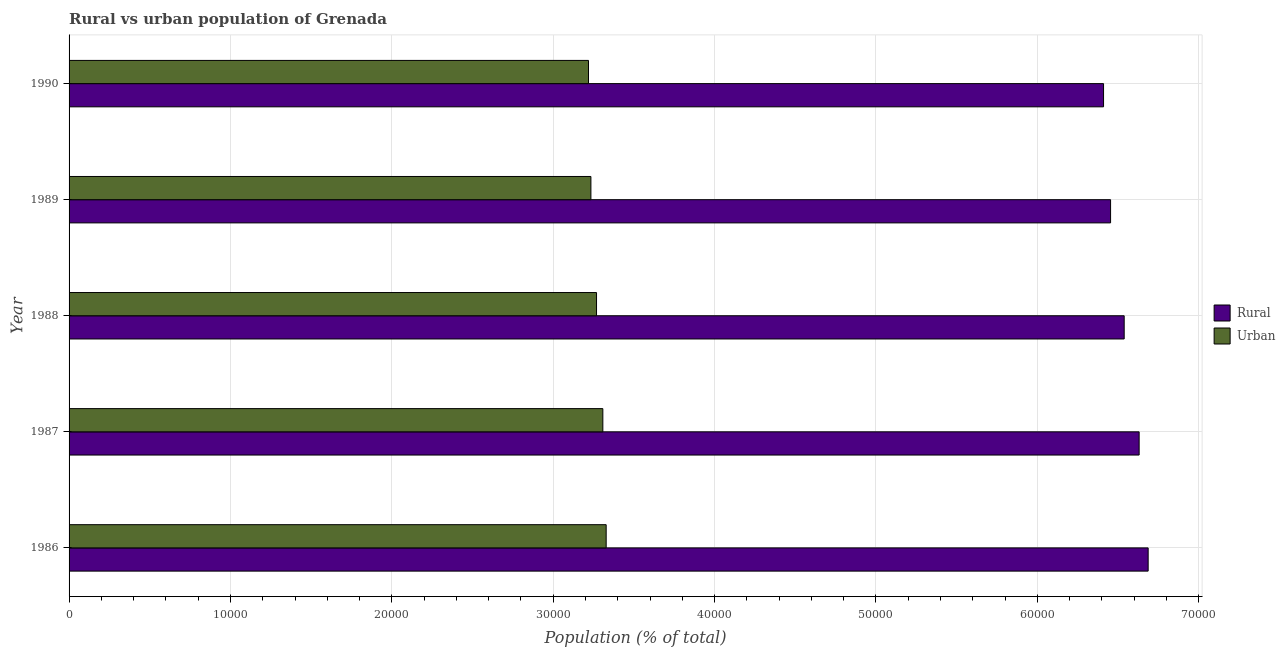How many different coloured bars are there?
Give a very brief answer. 2. Are the number of bars on each tick of the Y-axis equal?
Provide a succinct answer. Yes. How many bars are there on the 1st tick from the top?
Keep it short and to the point. 2. What is the label of the 2nd group of bars from the top?
Make the answer very short. 1989. What is the rural population density in 1986?
Keep it short and to the point. 6.69e+04. Across all years, what is the maximum urban population density?
Offer a terse response. 3.33e+04. Across all years, what is the minimum rural population density?
Offer a very short reply. 6.41e+04. What is the total rural population density in the graph?
Offer a terse response. 3.27e+05. What is the difference between the rural population density in 1986 and that in 1989?
Provide a short and direct response. 2329. What is the difference between the rural population density in 1988 and the urban population density in 1986?
Your response must be concise. 3.21e+04. What is the average rural population density per year?
Provide a succinct answer. 6.54e+04. In the year 1988, what is the difference between the urban population density and rural population density?
Provide a short and direct response. -3.27e+04. What is the ratio of the urban population density in 1986 to that in 1990?
Provide a short and direct response. 1.03. Is the rural population density in 1987 less than that in 1990?
Provide a short and direct response. No. What is the difference between the highest and the second highest urban population density?
Provide a short and direct response. 206. What is the difference between the highest and the lowest rural population density?
Offer a terse response. 2765. In how many years, is the urban population density greater than the average urban population density taken over all years?
Make the answer very short. 2. Is the sum of the rural population density in 1987 and 1988 greater than the maximum urban population density across all years?
Keep it short and to the point. Yes. What does the 2nd bar from the top in 1987 represents?
Give a very brief answer. Rural. What does the 2nd bar from the bottom in 1988 represents?
Your response must be concise. Urban. Are the values on the major ticks of X-axis written in scientific E-notation?
Ensure brevity in your answer.  No. Does the graph contain any zero values?
Make the answer very short. No. Where does the legend appear in the graph?
Give a very brief answer. Center right. How are the legend labels stacked?
Provide a short and direct response. Vertical. What is the title of the graph?
Make the answer very short. Rural vs urban population of Grenada. Does "Private credit bureau" appear as one of the legend labels in the graph?
Keep it short and to the point. No. What is the label or title of the X-axis?
Offer a very short reply. Population (% of total). What is the Population (% of total) in Rural in 1986?
Offer a very short reply. 6.69e+04. What is the Population (% of total) of Urban in 1986?
Provide a succinct answer. 3.33e+04. What is the Population (% of total) in Rural in 1987?
Your answer should be compact. 6.63e+04. What is the Population (% of total) in Urban in 1987?
Your response must be concise. 3.31e+04. What is the Population (% of total) of Rural in 1988?
Provide a succinct answer. 6.54e+04. What is the Population (% of total) in Urban in 1988?
Ensure brevity in your answer.  3.27e+04. What is the Population (% of total) in Rural in 1989?
Give a very brief answer. 6.45e+04. What is the Population (% of total) of Urban in 1989?
Keep it short and to the point. 3.23e+04. What is the Population (% of total) in Rural in 1990?
Provide a short and direct response. 6.41e+04. What is the Population (% of total) of Urban in 1990?
Your response must be concise. 3.22e+04. Across all years, what is the maximum Population (% of total) of Rural?
Make the answer very short. 6.69e+04. Across all years, what is the maximum Population (% of total) of Urban?
Provide a short and direct response. 3.33e+04. Across all years, what is the minimum Population (% of total) in Rural?
Give a very brief answer. 6.41e+04. Across all years, what is the minimum Population (% of total) of Urban?
Provide a short and direct response. 3.22e+04. What is the total Population (% of total) in Rural in the graph?
Offer a terse response. 3.27e+05. What is the total Population (% of total) of Urban in the graph?
Provide a succinct answer. 1.64e+05. What is the difference between the Population (% of total) of Rural in 1986 and that in 1987?
Ensure brevity in your answer.  559. What is the difference between the Population (% of total) of Urban in 1986 and that in 1987?
Provide a succinct answer. 206. What is the difference between the Population (% of total) of Rural in 1986 and that in 1988?
Your response must be concise. 1486. What is the difference between the Population (% of total) of Urban in 1986 and that in 1988?
Your answer should be very brief. 597. What is the difference between the Population (% of total) in Rural in 1986 and that in 1989?
Give a very brief answer. 2329. What is the difference between the Population (% of total) of Urban in 1986 and that in 1989?
Your answer should be compact. 946. What is the difference between the Population (% of total) of Rural in 1986 and that in 1990?
Make the answer very short. 2765. What is the difference between the Population (% of total) of Urban in 1986 and that in 1990?
Your response must be concise. 1095. What is the difference between the Population (% of total) of Rural in 1987 and that in 1988?
Your response must be concise. 927. What is the difference between the Population (% of total) in Urban in 1987 and that in 1988?
Your answer should be compact. 391. What is the difference between the Population (% of total) of Rural in 1987 and that in 1989?
Give a very brief answer. 1770. What is the difference between the Population (% of total) of Urban in 1987 and that in 1989?
Keep it short and to the point. 740. What is the difference between the Population (% of total) in Rural in 1987 and that in 1990?
Your response must be concise. 2206. What is the difference between the Population (% of total) in Urban in 1987 and that in 1990?
Give a very brief answer. 889. What is the difference between the Population (% of total) of Rural in 1988 and that in 1989?
Ensure brevity in your answer.  843. What is the difference between the Population (% of total) in Urban in 1988 and that in 1989?
Offer a very short reply. 349. What is the difference between the Population (% of total) in Rural in 1988 and that in 1990?
Give a very brief answer. 1279. What is the difference between the Population (% of total) of Urban in 1988 and that in 1990?
Make the answer very short. 498. What is the difference between the Population (% of total) in Rural in 1989 and that in 1990?
Your response must be concise. 436. What is the difference between the Population (% of total) in Urban in 1989 and that in 1990?
Your answer should be very brief. 149. What is the difference between the Population (% of total) in Rural in 1986 and the Population (% of total) in Urban in 1987?
Give a very brief answer. 3.38e+04. What is the difference between the Population (% of total) of Rural in 1986 and the Population (% of total) of Urban in 1988?
Give a very brief answer. 3.42e+04. What is the difference between the Population (% of total) of Rural in 1986 and the Population (% of total) of Urban in 1989?
Your response must be concise. 3.45e+04. What is the difference between the Population (% of total) in Rural in 1986 and the Population (% of total) in Urban in 1990?
Provide a short and direct response. 3.47e+04. What is the difference between the Population (% of total) of Rural in 1987 and the Population (% of total) of Urban in 1988?
Provide a succinct answer. 3.36e+04. What is the difference between the Population (% of total) of Rural in 1987 and the Population (% of total) of Urban in 1989?
Provide a short and direct response. 3.40e+04. What is the difference between the Population (% of total) in Rural in 1987 and the Population (% of total) in Urban in 1990?
Your response must be concise. 3.41e+04. What is the difference between the Population (% of total) in Rural in 1988 and the Population (% of total) in Urban in 1989?
Make the answer very short. 3.30e+04. What is the difference between the Population (% of total) in Rural in 1988 and the Population (% of total) in Urban in 1990?
Provide a succinct answer. 3.32e+04. What is the difference between the Population (% of total) in Rural in 1989 and the Population (% of total) in Urban in 1990?
Offer a terse response. 3.24e+04. What is the average Population (% of total) of Rural per year?
Ensure brevity in your answer.  6.54e+04. What is the average Population (% of total) in Urban per year?
Keep it short and to the point. 3.27e+04. In the year 1986, what is the difference between the Population (% of total) of Rural and Population (% of total) of Urban?
Offer a terse response. 3.36e+04. In the year 1987, what is the difference between the Population (% of total) in Rural and Population (% of total) in Urban?
Your response must be concise. 3.32e+04. In the year 1988, what is the difference between the Population (% of total) of Rural and Population (% of total) of Urban?
Provide a succinct answer. 3.27e+04. In the year 1989, what is the difference between the Population (% of total) in Rural and Population (% of total) in Urban?
Provide a short and direct response. 3.22e+04. In the year 1990, what is the difference between the Population (% of total) in Rural and Population (% of total) in Urban?
Offer a very short reply. 3.19e+04. What is the ratio of the Population (% of total) of Rural in 1986 to that in 1987?
Provide a succinct answer. 1.01. What is the ratio of the Population (% of total) of Rural in 1986 to that in 1988?
Your response must be concise. 1.02. What is the ratio of the Population (% of total) of Urban in 1986 to that in 1988?
Your response must be concise. 1.02. What is the ratio of the Population (% of total) of Rural in 1986 to that in 1989?
Your response must be concise. 1.04. What is the ratio of the Population (% of total) of Urban in 1986 to that in 1989?
Provide a short and direct response. 1.03. What is the ratio of the Population (% of total) of Rural in 1986 to that in 1990?
Ensure brevity in your answer.  1.04. What is the ratio of the Population (% of total) of Urban in 1986 to that in 1990?
Keep it short and to the point. 1.03. What is the ratio of the Population (% of total) of Rural in 1987 to that in 1988?
Your answer should be very brief. 1.01. What is the ratio of the Population (% of total) in Rural in 1987 to that in 1989?
Ensure brevity in your answer.  1.03. What is the ratio of the Population (% of total) in Urban in 1987 to that in 1989?
Your answer should be compact. 1.02. What is the ratio of the Population (% of total) in Rural in 1987 to that in 1990?
Your answer should be very brief. 1.03. What is the ratio of the Population (% of total) of Urban in 1987 to that in 1990?
Make the answer very short. 1.03. What is the ratio of the Population (% of total) in Rural in 1988 to that in 1989?
Offer a terse response. 1.01. What is the ratio of the Population (% of total) in Urban in 1988 to that in 1989?
Give a very brief answer. 1.01. What is the ratio of the Population (% of total) of Rural in 1988 to that in 1990?
Give a very brief answer. 1.02. What is the ratio of the Population (% of total) in Urban in 1988 to that in 1990?
Provide a succinct answer. 1.02. What is the ratio of the Population (% of total) of Rural in 1989 to that in 1990?
Your answer should be compact. 1.01. What is the difference between the highest and the second highest Population (% of total) in Rural?
Your answer should be compact. 559. What is the difference between the highest and the second highest Population (% of total) in Urban?
Keep it short and to the point. 206. What is the difference between the highest and the lowest Population (% of total) in Rural?
Your answer should be compact. 2765. What is the difference between the highest and the lowest Population (% of total) in Urban?
Your response must be concise. 1095. 